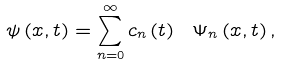Convert formula to latex. <formula><loc_0><loc_0><loc_500><loc_500>\psi \left ( x , t \right ) = \sum _ { n = 0 } ^ { \infty } c _ { n } \left ( t \right ) \ \Psi _ { n } \left ( x , t \right ) ,</formula> 